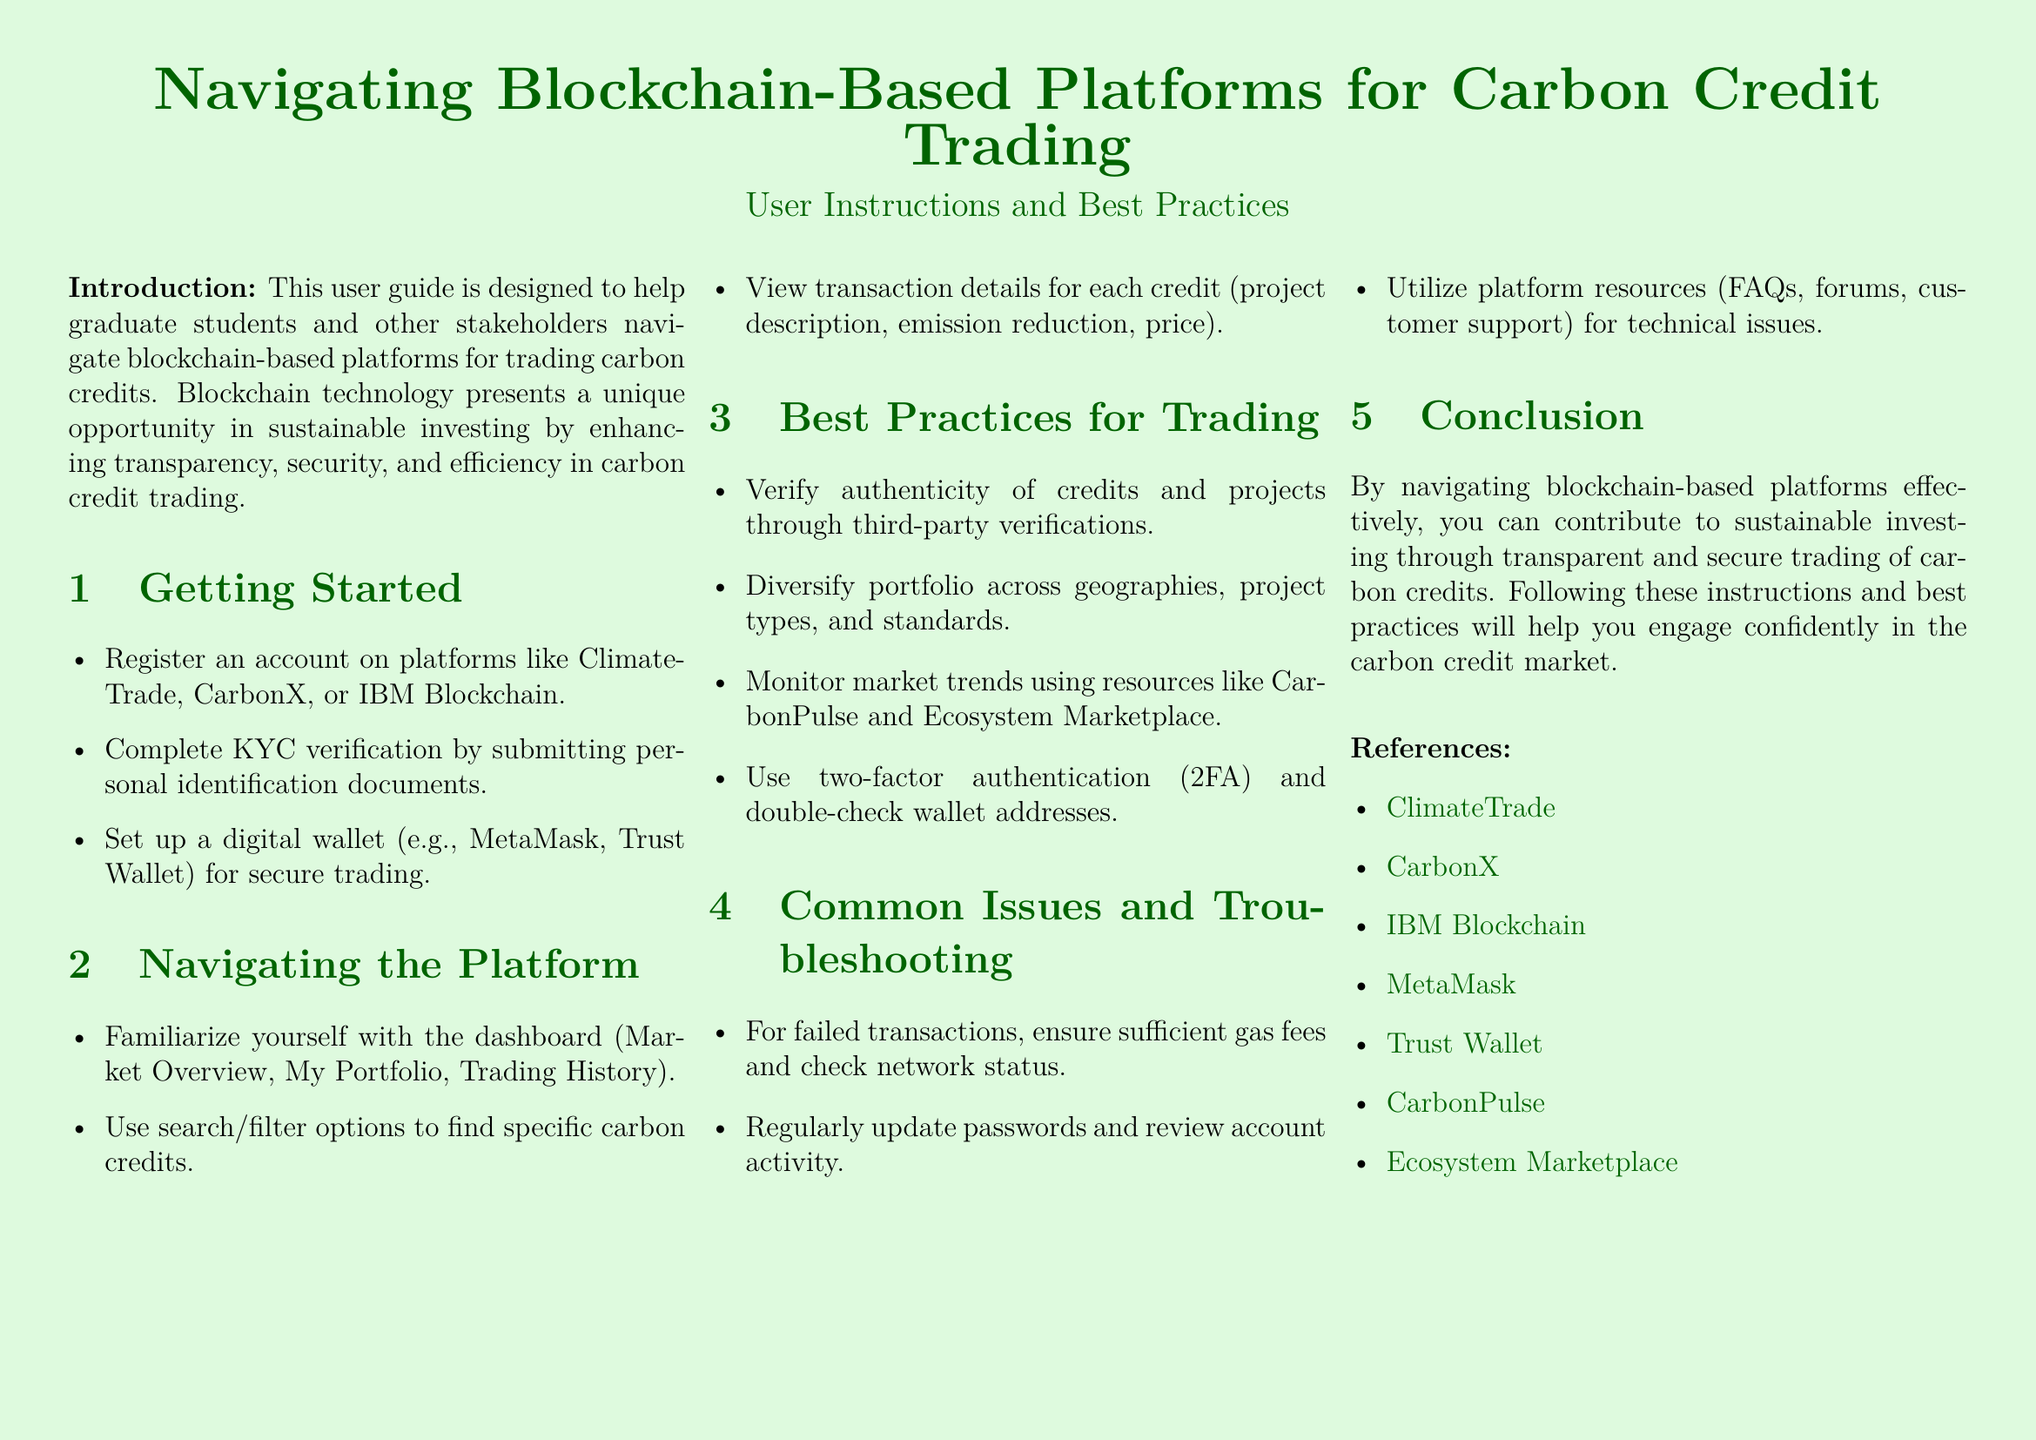What are some platforms mentioned for carbon credit trading? The document lists ClimateTrade, CarbonX, and IBM Blockchain as platforms for trading carbon credits.
Answer: ClimateTrade, CarbonX, IBM Blockchain What should you submit to complete KYC verification? The document states that personal identification documents need to be submitted for KYC verification.
Answer: Personal identification documents What type of digital wallet is recommended in the document? The document recommends using wallets like MetaMask or Trust Wallet for secure trading.
Answer: MetaMask, Trust Wallet What is the first step in getting started with a blockchain platform? The document states that registering an account on a platform is the first step to getting started.
Answer: Register an account What is a best practice for verifying carbon credits? The document advises verifying the authenticity of credits and projects through third-party verifications.
Answer: Third-party verifications What should you monitor according to best practices? The document mentions monitoring market trends using resources like CarbonPulse and Ecosystem Marketplace.
Answer: Market trends What is a recommended security feature for accounts? The document suggests using two-factor authentication (2FA) as a security measure.
Answer: Two-factor authentication (2FA) What should you check for failed transactions? The document indicates checking sufficient gas fees and network status for failed transactions.
Answer: Sufficient gas fees, network status What type of issues can you find solutions for in platform resources? The document mentions that platform resources can help with technical issues.
Answer: Technical issues 